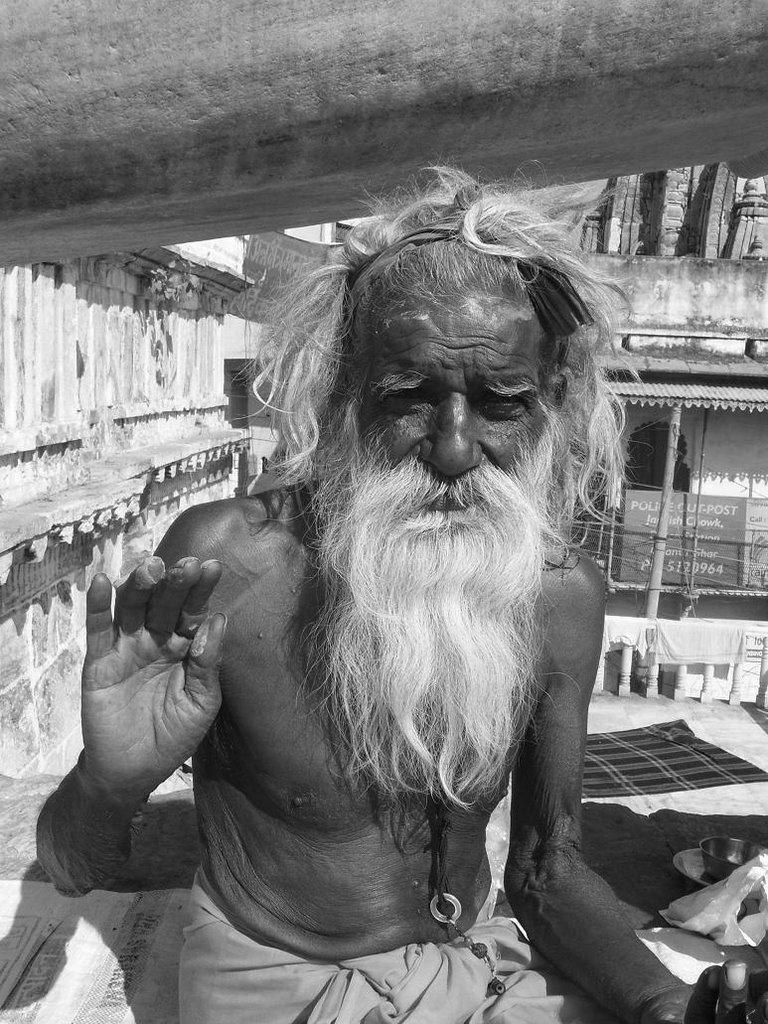Can you describe this image briefly? In this picture there is a man who is wearing locket and trouser. On the background we can see a monument. Besides him we can see plastic cover and mat. On the right there is a banner. 